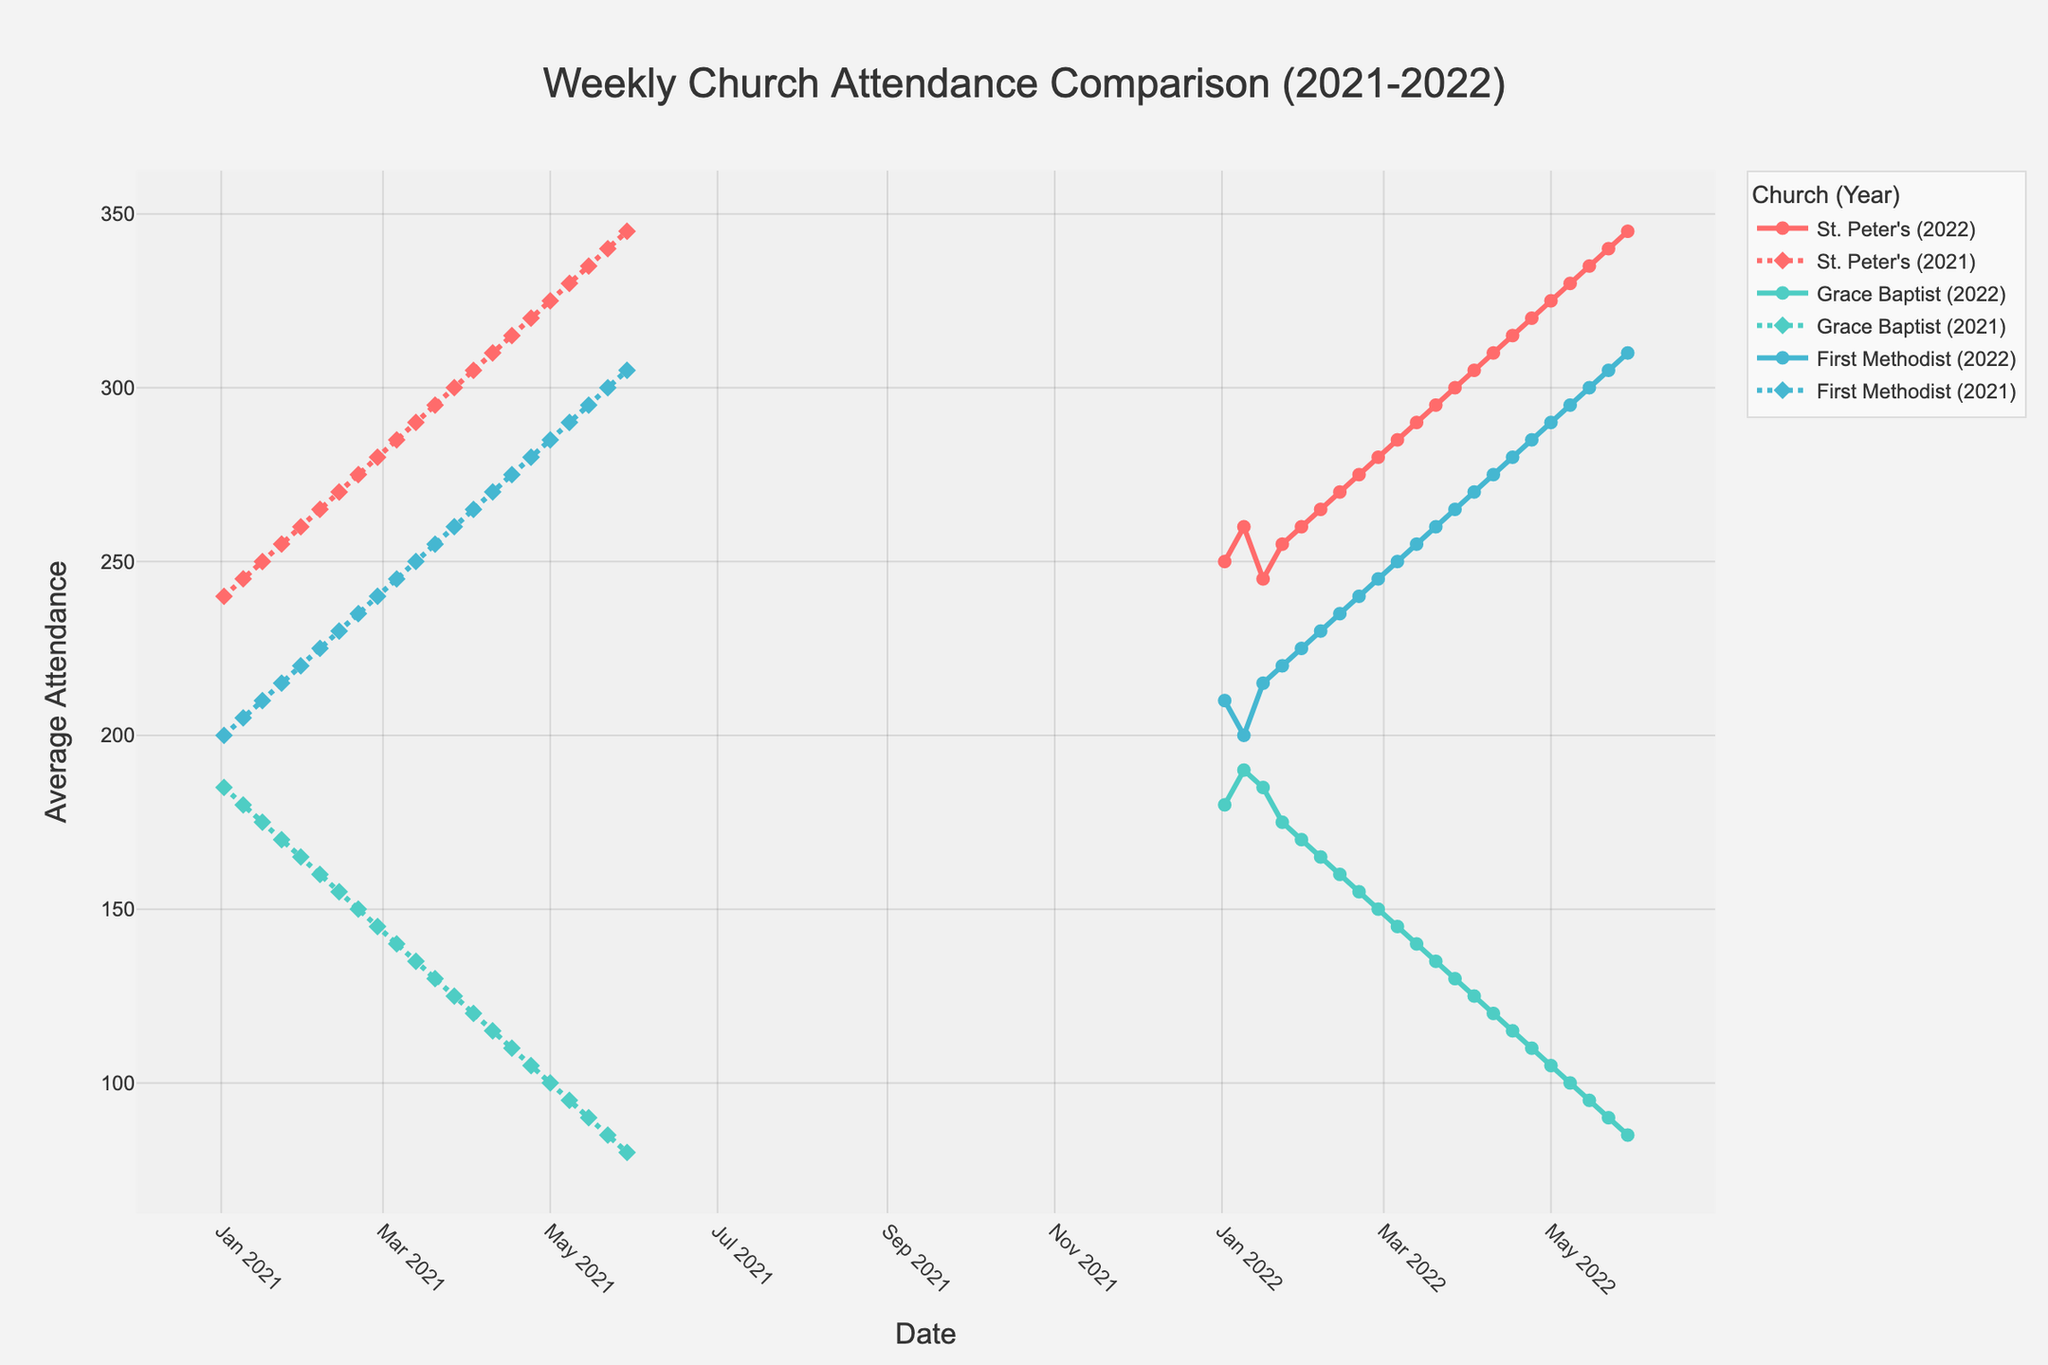What is the title of the figure? The title of the figure is typically displayed prominently at the top of the chart. It is used to provide context and summarize the data being presented.
Answer: Weekly Church Attendance Comparison (2021-2022) Which church had the lowest average attendance at the end of May 2022? To answer this, find the data points corresponding to the end of May 2022 and compare the average attendance across the three churches.
Answer: Grace Baptist How does the attendance trend of St. Peter's in 2021 compare to 2022? Examine the patterns in the lines for St. Peter's in both years. Identify whether the attendance generally increased, decreased, or stayed the same from January to May in each year.
Answer: Both years show a general increase, but the increase is steeper in 2022 What was the highest recorded attendance for Grace Baptist in 2021? Look at the data points for Grace Baptist in 2021 and identify the maximum value.
Answer: 185 By how much did First Methodist's average attendance change from the first week of January to the last week of May in 2022? Find the attendance values for the first week of January and the last week of May. Compute the difference between these two values to determine the change.
Answer: 100 Which year had a higher average attendance for St. Peter's in March, 2021 or 2022? Compare the average attendance values for St. Peter's in the month of March for both years by examining the corresponding data points.
Answer: 2022 What is the shape of the marker used for Grace Baptist in 2022, and what does it signify? Identify the marker shapes used in the figure legend and visual cues on the plot. The marker shape helps distinguish different years.
Answer: Circle, signifies data from 2022 Which week showed the largest single-week increase in attendance for First Methodist in 2022? Identify the difference in attendance from week to week for First Methodist in 2022, and find the week with the largest positive change.
Answer: Week of 2022-01-23 How does the attendance pattern of Grace Baptist in 2022 compare to its pattern in 2021? Compare the overall trends of Grace Baptist in both years. Identify whether the attendance increased, decreased, or fluctuated and note the consistency of these patterns.
Answer: Attendance steadily decreased in both years, but the decline was sharper in 2022 